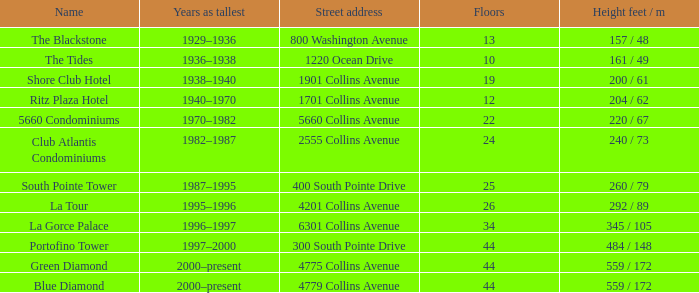What is the height of tides buildings with fewer than 34 floors? 161 / 49. 